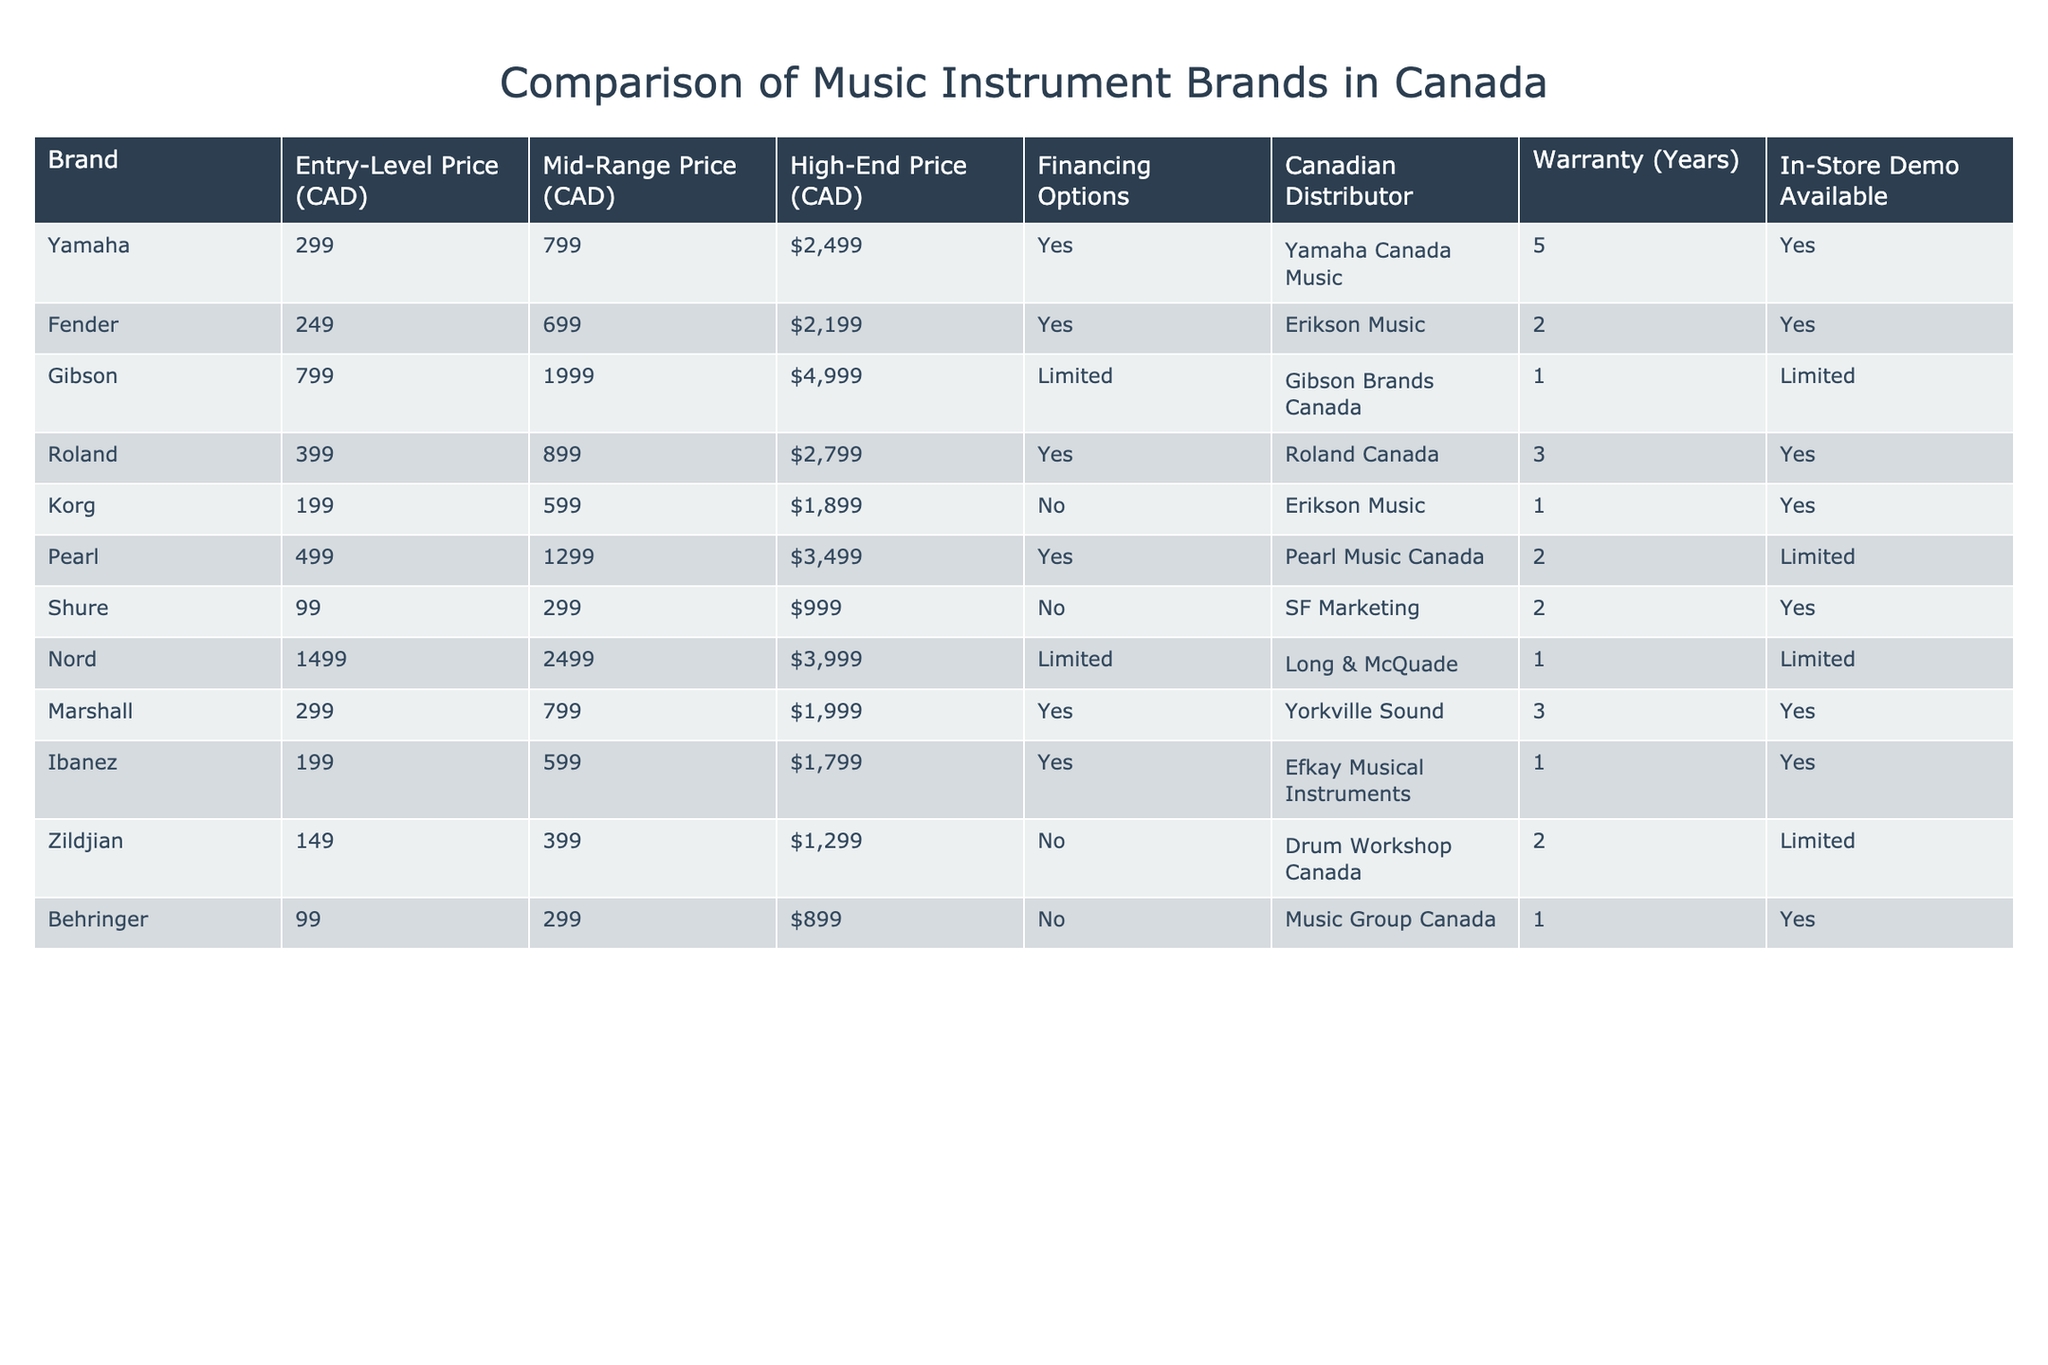What is the entry-level price of Yamaha instruments? According to the table, the entry-level price for Yamaha instruments is listed as 299 CAD.
Answer: 299 CAD Which brand has the highest high-end price? The highest high-end price is for Gibson, which is 4999 CAD. This can be seen directly from the high-end price column.
Answer: Gibson, 4999 CAD How many brands offer financing options? By looking at the 'Financing Options' column, the brands that offer financing are Yamaha, Fender, Roland, Pearl, Marshall, and Ibanez. This gives us a total of 6 brands.
Answer: 6 brands What is the average mid-range price of all brands? To find the average, we add all the mid-range prices: 799 + 699 + 1999 + 899 + 599 + 1299 + 299 + 2499 + 799 + 599 + 399 + 299 = 13359. There are 12 brands, so the average mid-range price is 13359 / 12 = 1113.25 CAD.
Answer: 1113.25 CAD Is there a brand that does not offer any warranty? Yes, Nord is the only brand that has a limited warranty of just 1 year, which implies it is not particularly competitive in terms of warranty length compared to others.
Answer: Yes, Nord 